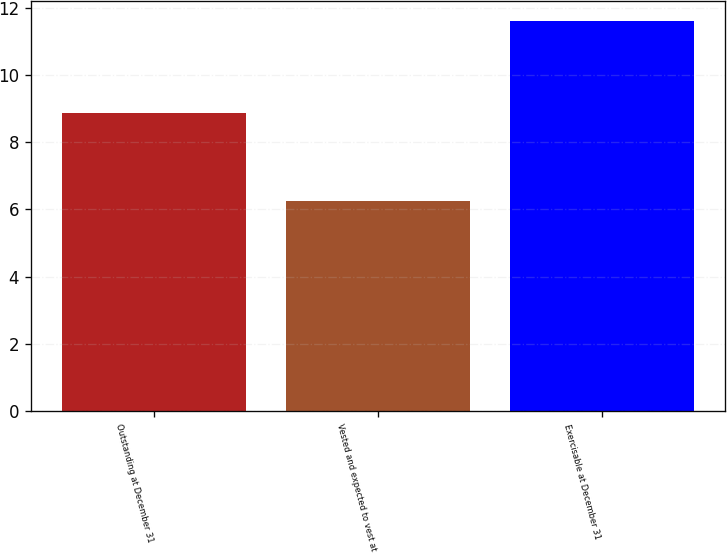Convert chart. <chart><loc_0><loc_0><loc_500><loc_500><bar_chart><fcel>Outstanding at December 31<fcel>Vested and expected to vest at<fcel>Exercisable at December 31<nl><fcel>8.87<fcel>6.26<fcel>11.61<nl></chart> 